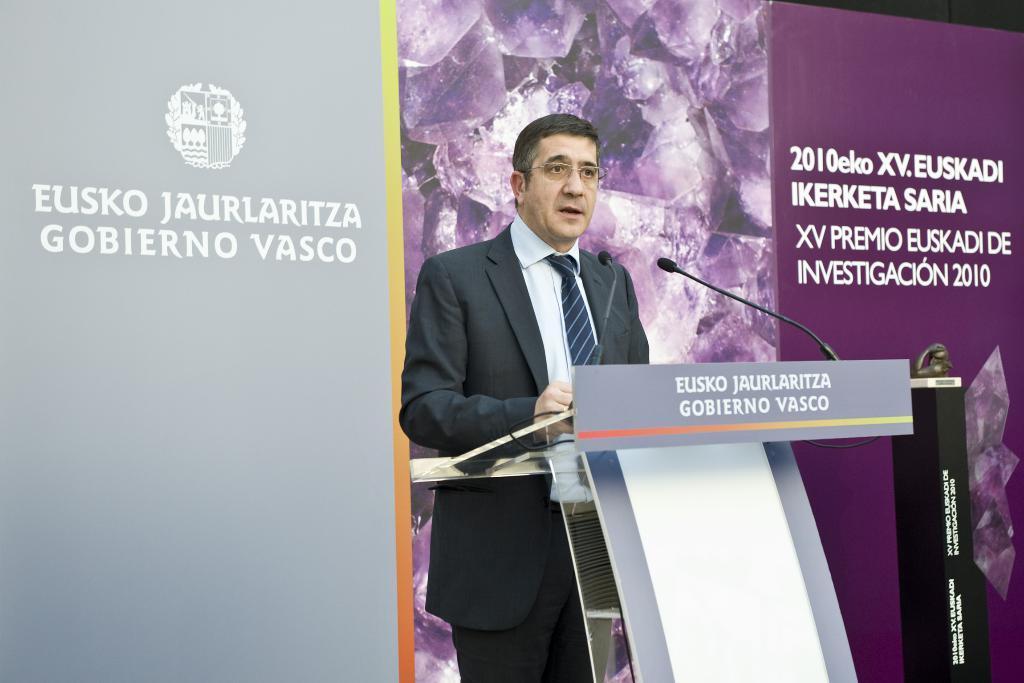Could you give a brief overview of what you see in this image? In this image I can see a man wearing a suit, standing in front of the podium and speaking on the microphone. To the podium I can see some text. In the background there is a board on which I can see some text. 